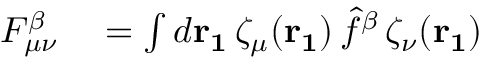<formula> <loc_0><loc_0><loc_500><loc_500>\begin{array} { r l } { F _ { \mu \nu } ^ { \beta } } & = \int d r _ { 1 } \, \zeta _ { \mu } ( r _ { 1 } ) \, \hat { f } ^ { \beta } \, \zeta _ { \nu } ( r _ { 1 } ) } \end{array}</formula> 